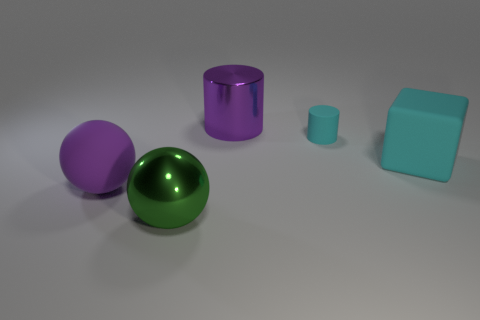Add 5 cyan things. How many objects exist? 10 Subtract all cylinders. How many objects are left? 3 Subtract all large matte cubes. Subtract all big green metallic balls. How many objects are left? 3 Add 1 large cylinders. How many large cylinders are left? 2 Add 1 rubber things. How many rubber things exist? 4 Subtract 0 red blocks. How many objects are left? 5 